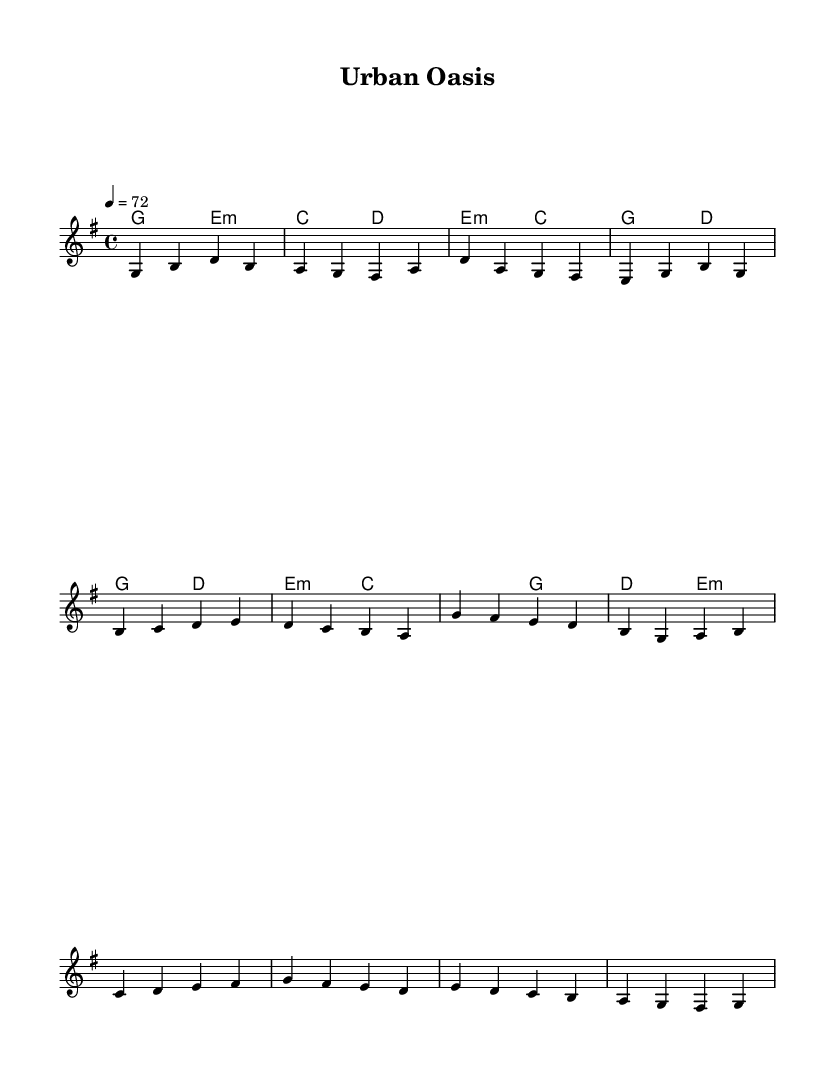What is the time signature of this music? The time signature is indicated at the beginning of the score, showing a 4 over 4, which means there are four beats in each measure and a quarter note receives one beat.
Answer: 4/4 What is the key signature of this music? The key signature is found at the beginning of the staff and shows one sharp, indicating that the piece is in G major.
Answer: G major What is the tempo marking for this piece? The tempo marking is indicated in beats per minute at the start, showing a quarter note equals seventy-two beats per minute, which sets the pace for the music.
Answer: seventy-two How many measures are there in the melody section? By counting the measures in the indicated melody section, including verses, pre-chorus, chorus, and bridge, we find there are a total of fifteen measures.
Answer: fifteen Which chord is played during the pre-chorus? The chords in the pre-chorus are specified in the chord mode section, showing an e minor chord followed by a c major chord, creating a transition into the chorus.
Answer: e minor What structure does the chorus of this piece follow? The chorus can be identified in the score as a distinct section with specific notes and chords, which sets it apart from the verses and pre-chorus, creating a more compelling climax in the music.
Answer: distinct section 